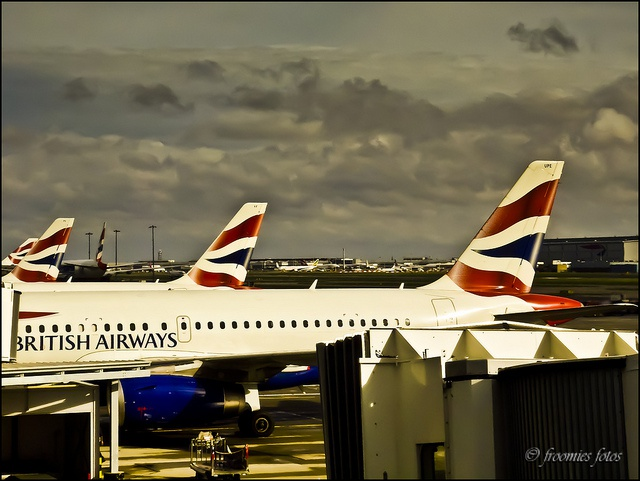Describe the objects in this image and their specific colors. I can see airplane in black, beige, khaki, and maroon tones, airplane in black, beige, and maroon tones, and airplane in black, beige, and tan tones in this image. 